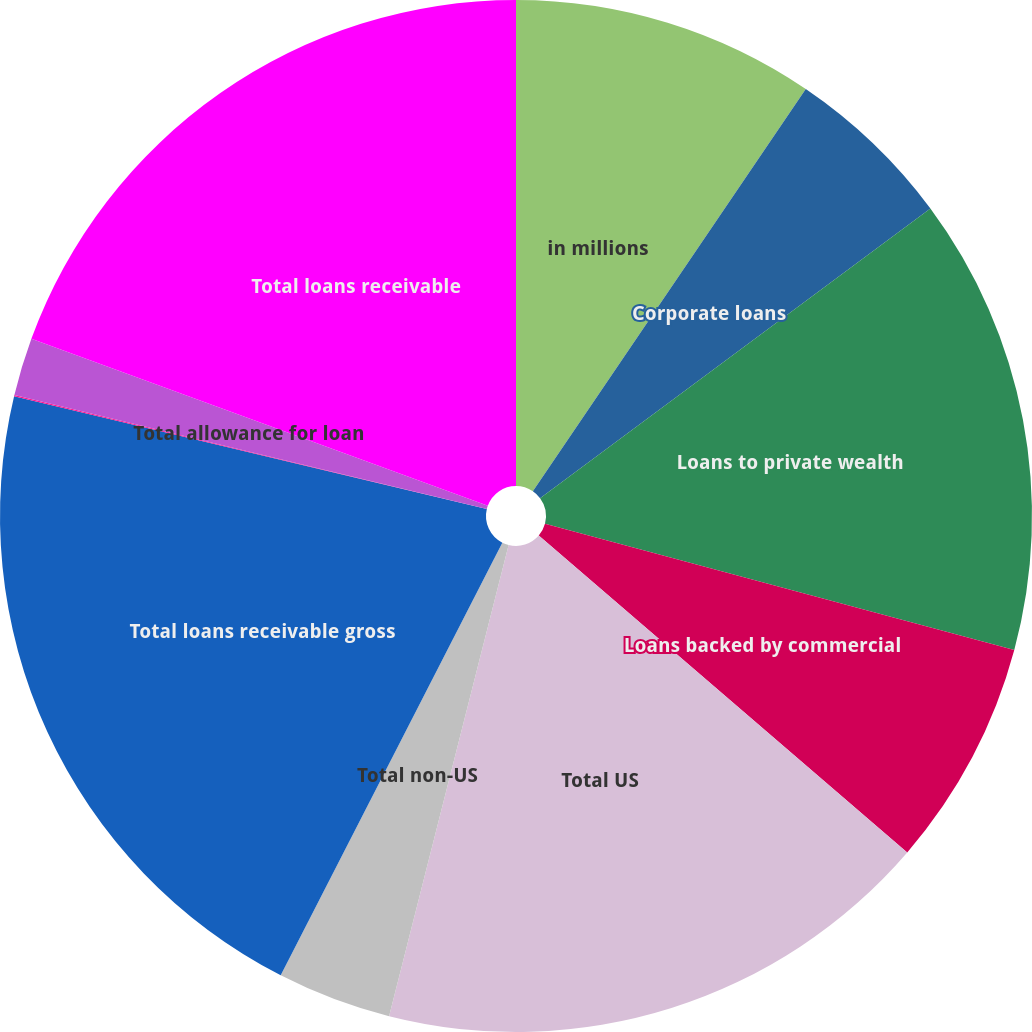Convert chart. <chart><loc_0><loc_0><loc_500><loc_500><pie_chart><fcel>in millions<fcel>Corporate loans<fcel>Loans to private wealth<fcel>Loans backed by commercial<fcel>Total US<fcel>Total non-US<fcel>Total loans receivable gross<fcel>US<fcel>Total allowance for loan<fcel>Total loans receivable<nl><fcel>9.49%<fcel>5.35%<fcel>14.34%<fcel>7.12%<fcel>17.65%<fcel>3.58%<fcel>21.19%<fcel>0.04%<fcel>1.81%<fcel>19.42%<nl></chart> 